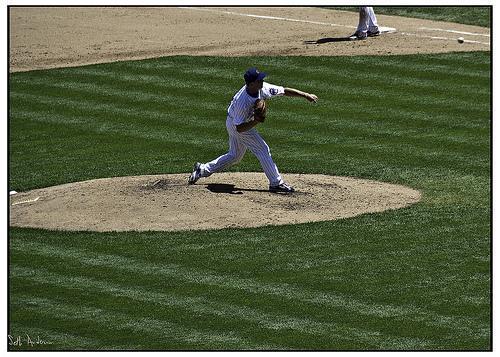How many people are photographed?
Give a very brief answer. 2. 